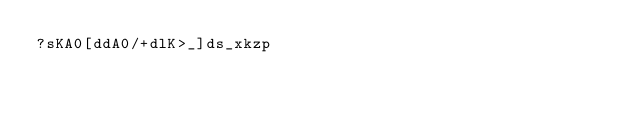<code> <loc_0><loc_0><loc_500><loc_500><_dc_>?sKA0[ddA0/+dlK>_]ds_xkzp</code> 